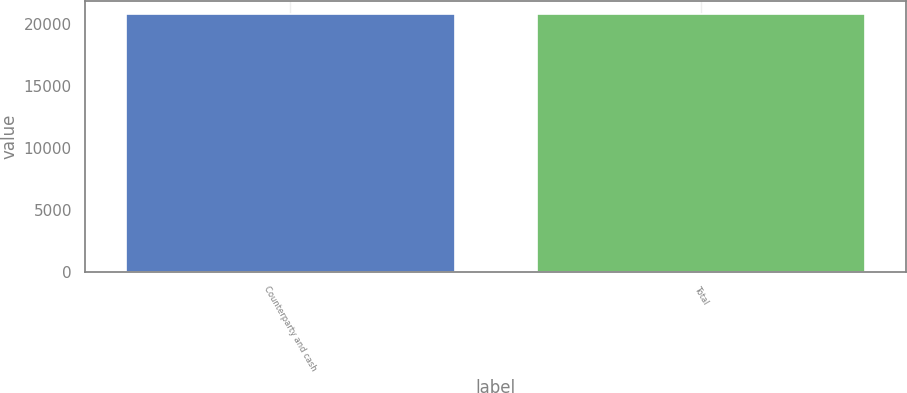Convert chart. <chart><loc_0><loc_0><loc_500><loc_500><bar_chart><fcel>Counterparty and cash<fcel>Total<nl><fcel>20819<fcel>20819.1<nl></chart> 